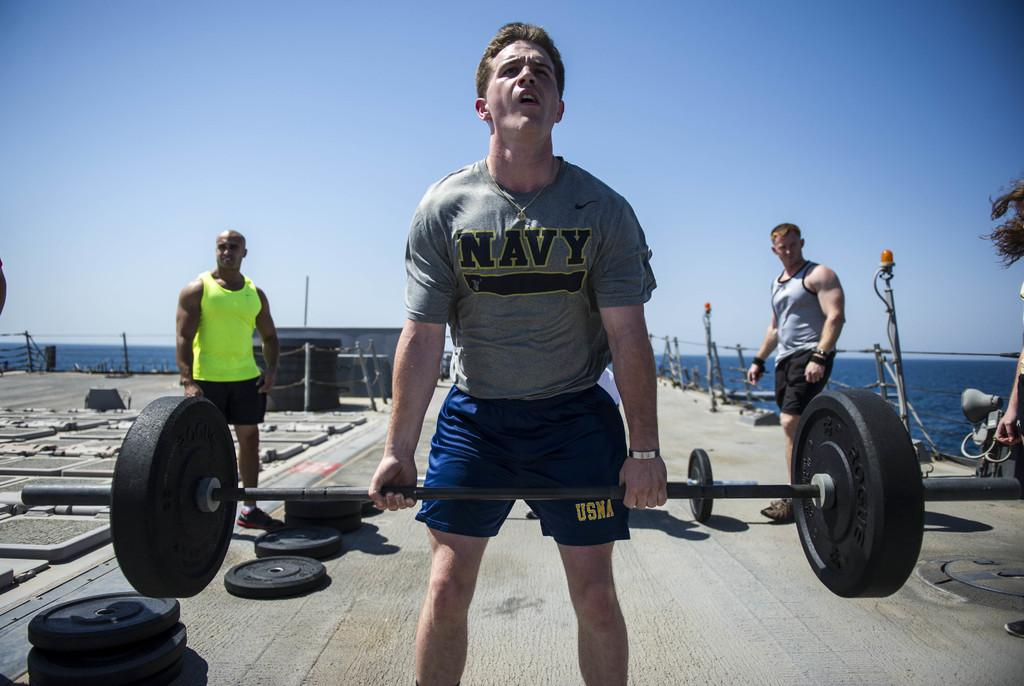<image>
Give a short and clear explanation of the subsequent image. Man lifting weights wearing a shirt that says NAVY. 